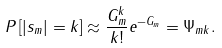<formula> <loc_0><loc_0><loc_500><loc_500>P \left [ | s _ { m } | = k \right ] \approx \frac { G _ { m } ^ { k } } { k ! } e ^ { - G _ { m } } = \Psi _ { m k } .</formula> 